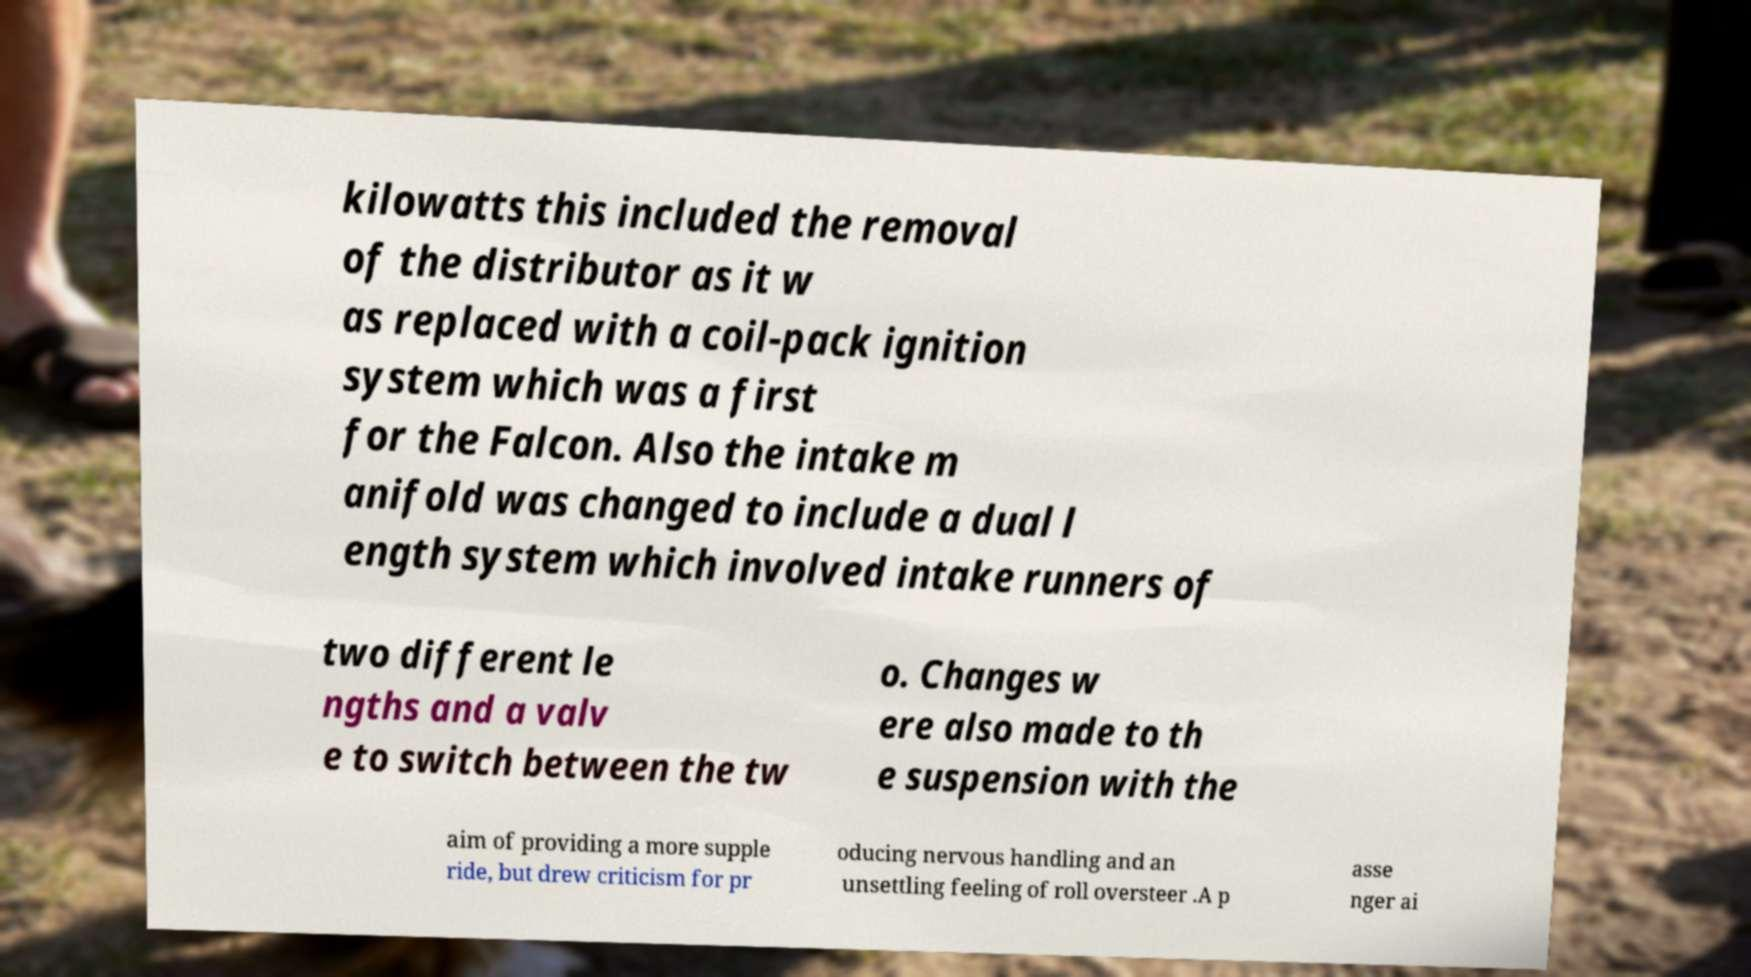Can you read and provide the text displayed in the image?This photo seems to have some interesting text. Can you extract and type it out for me? kilowatts this included the removal of the distributor as it w as replaced with a coil-pack ignition system which was a first for the Falcon. Also the intake m anifold was changed to include a dual l ength system which involved intake runners of two different le ngths and a valv e to switch between the tw o. Changes w ere also made to th e suspension with the aim of providing a more supple ride, but drew criticism for pr oducing nervous handling and an unsettling feeling of roll oversteer .A p asse nger ai 